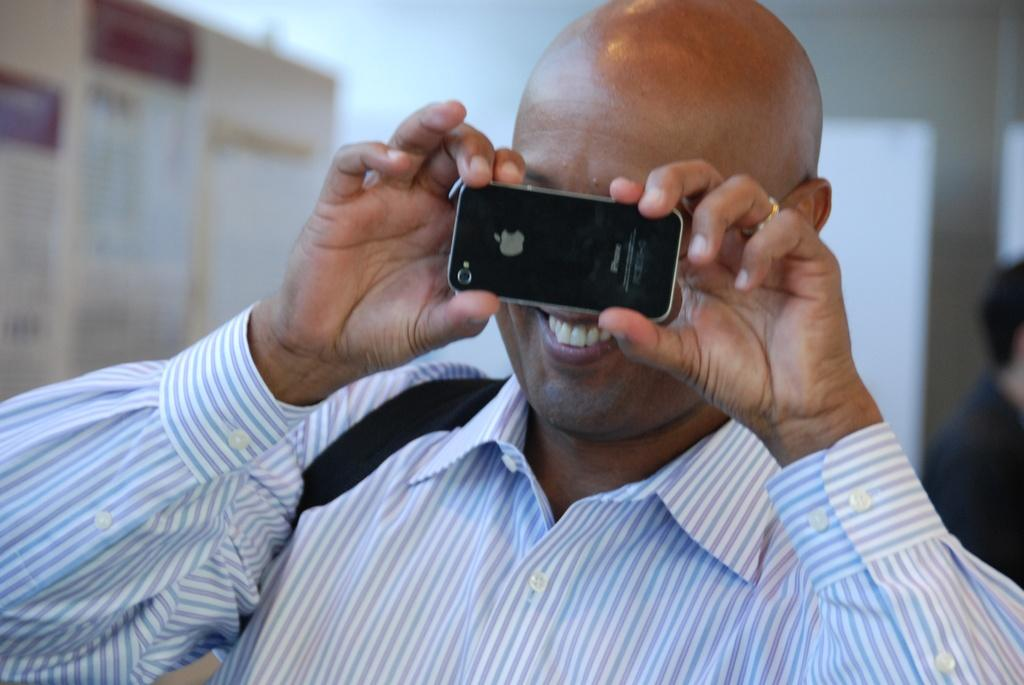What is the main subject of the image? There is a man in the image. Can you describe the man's appearance? The man has a shaved head. What is the man doing in the image? The man is standing and taking a picture with his mobile phone. What type of skate is the man using to take the picture? There is no skate present in the image; the man is using his mobile phone to take the picture. Can you tell me how many potatoes are visible in the image? There are no potatoes present in the image. 